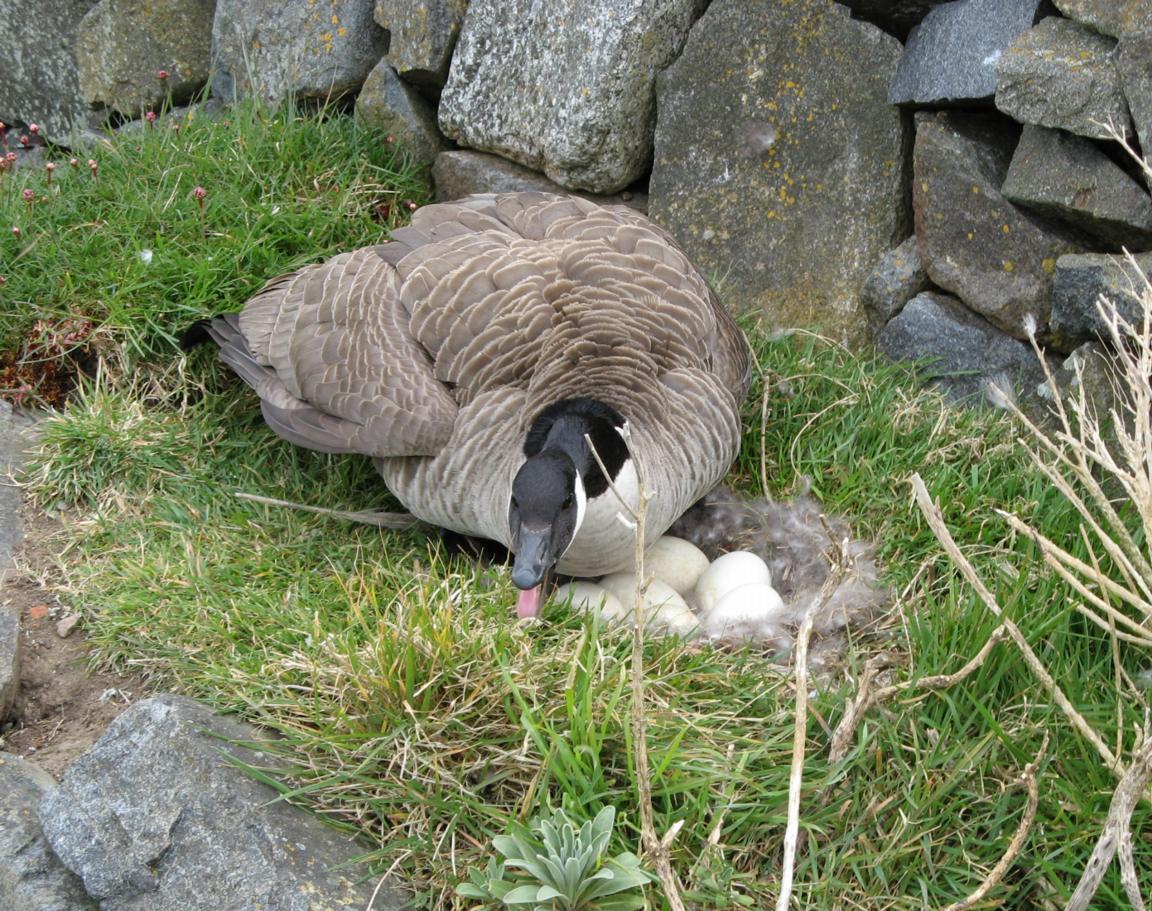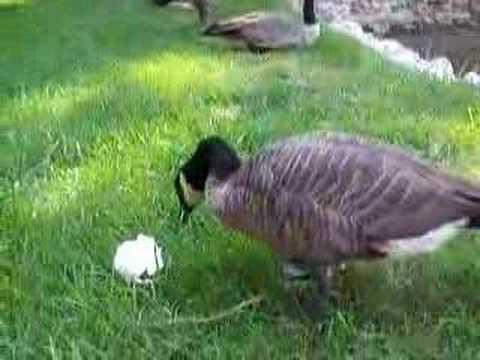The first image is the image on the left, the second image is the image on the right. Analyze the images presented: Is the assertion "The combined images include two geese with grey coloring bending their grey necks toward the grass." valid? Answer yes or no. No. The first image is the image on the left, the second image is the image on the right. Considering the images on both sides, is "The right image contains exactly one duck." valid? Answer yes or no. Yes. 